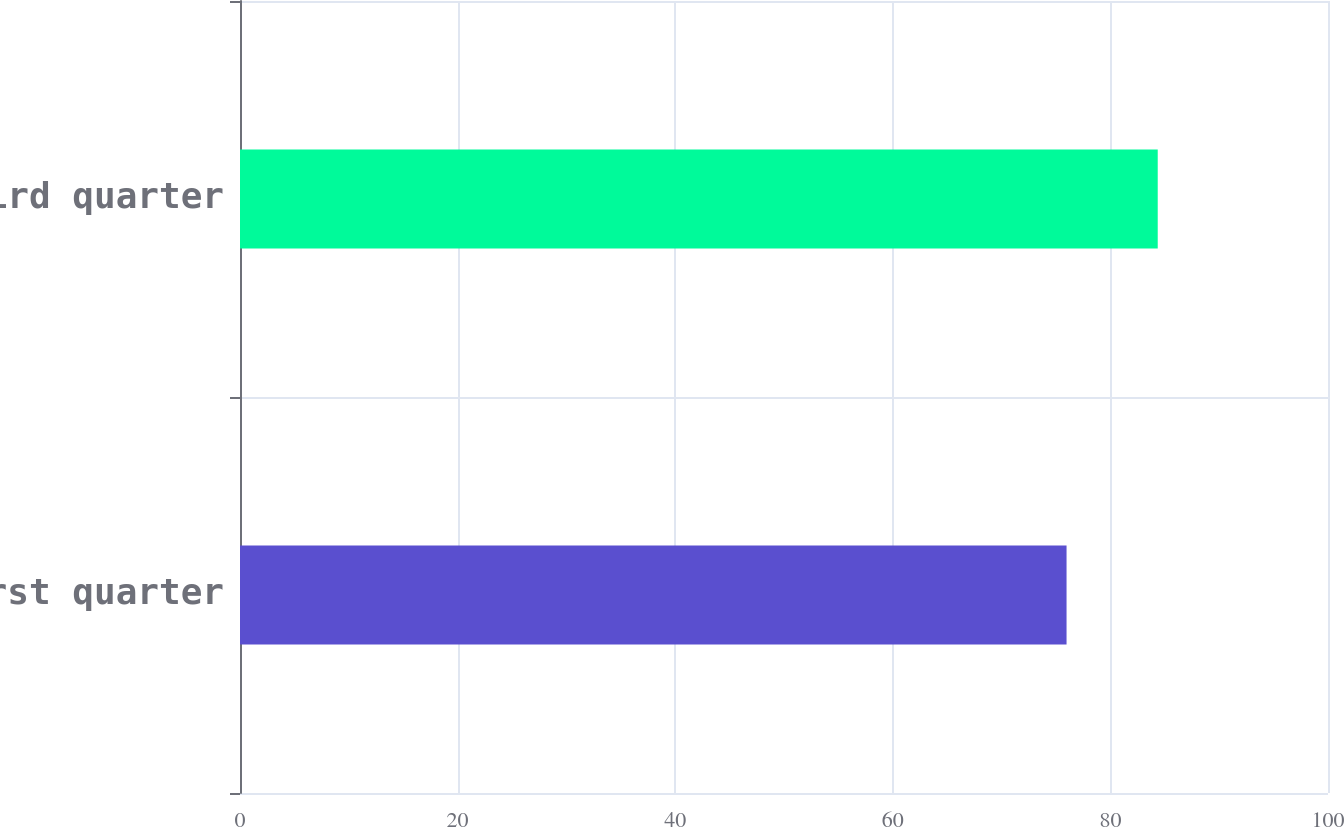<chart> <loc_0><loc_0><loc_500><loc_500><bar_chart><fcel>First quarter<fcel>Third quarter<nl><fcel>75.97<fcel>84.35<nl></chart> 